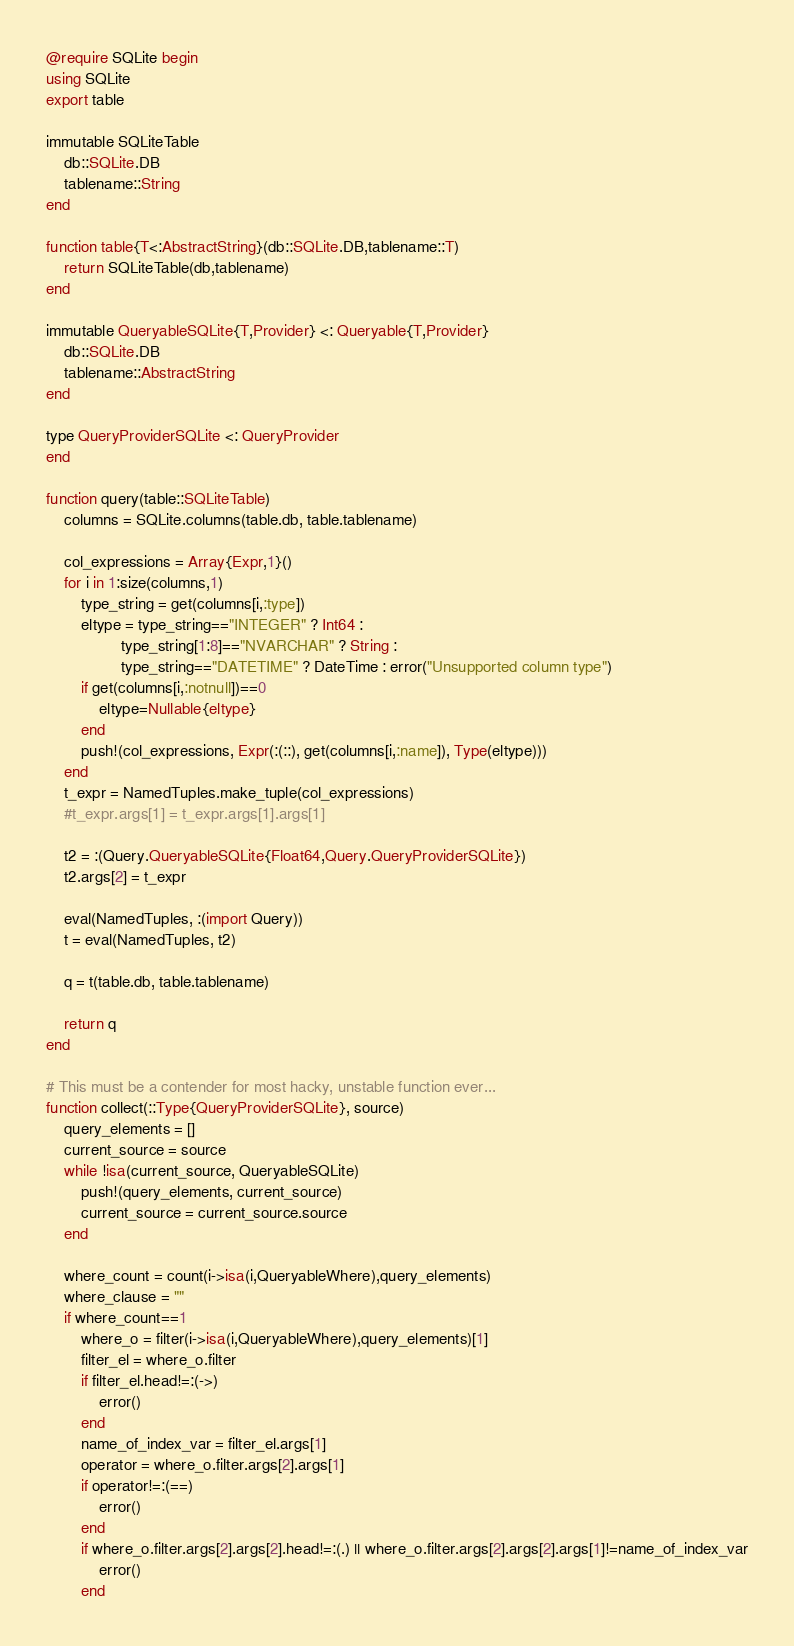Convert code to text. <code><loc_0><loc_0><loc_500><loc_500><_Julia_>@require SQLite begin
using SQLite
export table

immutable SQLiteTable
    db::SQLite.DB
    tablename::String
end

function table{T<:AbstractString}(db::SQLite.DB,tablename::T)
    return SQLiteTable(db,tablename)
end

immutable QueryableSQLite{T,Provider} <: Queryable{T,Provider}
    db::SQLite.DB
    tablename::AbstractString
end

type QueryProviderSQLite <: QueryProvider
end

function query(table::SQLiteTable)
	columns = SQLite.columns(table.db, table.tablename)

    col_expressions = Array{Expr,1}()
    for i in 1:size(columns,1)
    	type_string = get(columns[i,:type])
    	eltype = type_string=="INTEGER" ? Int64 :
    	         type_string[1:8]=="NVARCHAR" ? String :
    	         type_string=="DATETIME" ? DateTime : error("Unsupported column type")
    	if get(columns[i,:notnull])==0
    		eltype=Nullable{eltype}
    	end
        push!(col_expressions, Expr(:(::), get(columns[i,:name]), Type(eltype)))
    end
    t_expr = NamedTuples.make_tuple(col_expressions)
    #t_expr.args[1] = t_expr.args[1].args[1]

    t2 = :(Query.QueryableSQLite{Float64,Query.QueryProviderSQLite})
    t2.args[2] = t_expr

    eval(NamedTuples, :(import Query))
    t = eval(NamedTuples, t2)

    q = t(table.db, table.tablename)

    return q
end

# This must be a contender for most hacky, unstable function ever...
function collect(::Type{QueryProviderSQLite}, source)
    query_elements = []
    current_source = source
    while !isa(current_source, QueryableSQLite)
        push!(query_elements, current_source)
        current_source = current_source.source
    end

    where_count = count(i->isa(i,QueryableWhere),query_elements)
    where_clause = ""
    if where_count==1
    	where_o = filter(i->isa(i,QueryableWhere),query_elements)[1]
    	filter_el = where_o.filter
    	if filter_el.head!=:(->)
    		error()
    	end
    	name_of_index_var = filter_el.args[1]
    	operator = where_o.filter.args[2].args[1]
    	if operator!=:(==)
    		error()
    	end
    	if where_o.filter.args[2].args[2].head!=:(.) || where_o.filter.args[2].args[2].args[1]!=name_of_index_var
    		error()
    	end</code> 